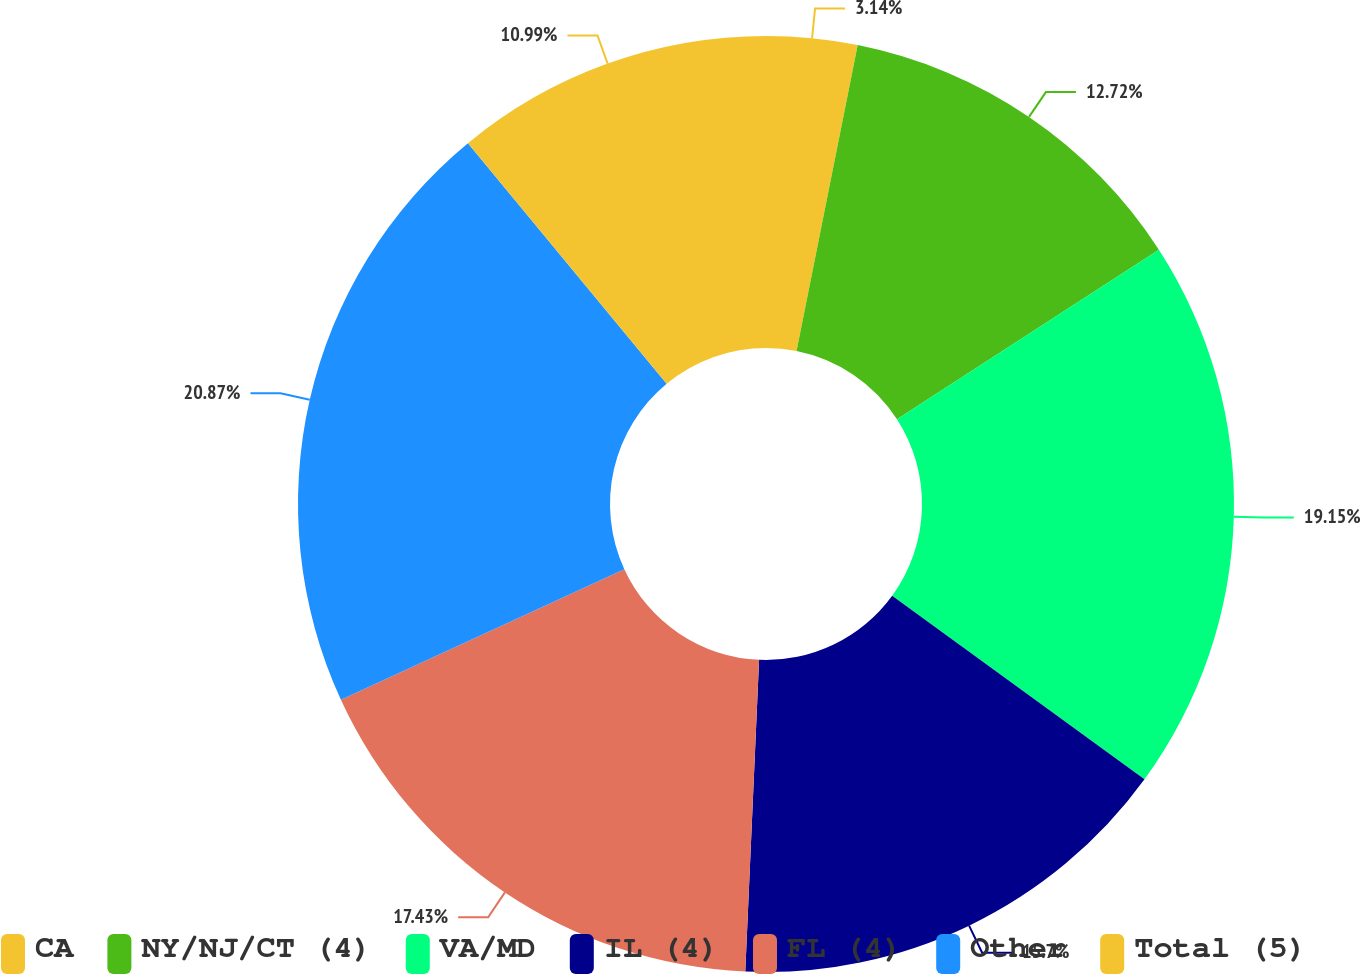Convert chart to OTSL. <chart><loc_0><loc_0><loc_500><loc_500><pie_chart><fcel>CA<fcel>NY/NJ/CT (4)<fcel>VA/MD<fcel>IL (4)<fcel>FL (4)<fcel>Other<fcel>Total (5)<nl><fcel>3.14%<fcel>12.72%<fcel>19.15%<fcel>15.7%<fcel>17.43%<fcel>20.88%<fcel>10.99%<nl></chart> 